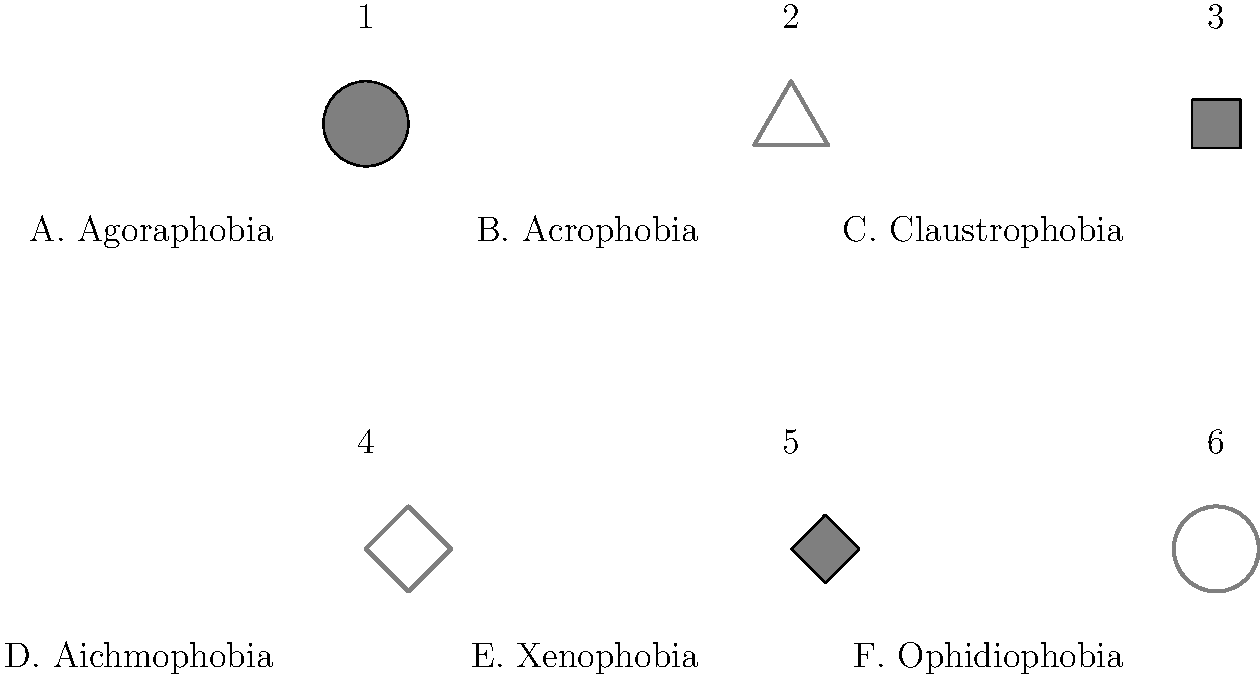As a quirky life coach specializing in phobias, you're hosting a "Face Your Fears" game show. Match the phobia names (A-F) with their corresponding fear objects represented by the simple icons (1-6). Which combination correctly pairs all phobias with their fear objects? Let's break this down step-by-step:

1. Agoraphobia (A): Fear of open or crowded spaces. The circular icon (1) represents an open space, so A1 is a match.

2. Acrophobia (B): Fear of heights. The triangle icon (2) can represent a mountain or tall structure, so B2 is a match.

3. Claustrophobia (C): Fear of confined spaces. The square icon (3) represents a small, enclosed space, so C3 is a match.

4. Aichmophobia (D): Fear of needles or sharp objects. The pointed shape icon (4) represents a sharp object, so D4 is a match.

5. Xenophobia (E): Fear of strangers or foreigners. The filled diamond shape (5) can represent a person or group that's different, so E5 is a match.

6. Ophidiophobia (F): Fear of snakes. The circular shape with an outline (6) can represent a coiled snake, so F6 is a match.

Therefore, the correct pairing of all phobias with their fear objects is: A1, B2, C3, D4, E5, F6.
Answer: A1, B2, C3, D4, E5, F6 